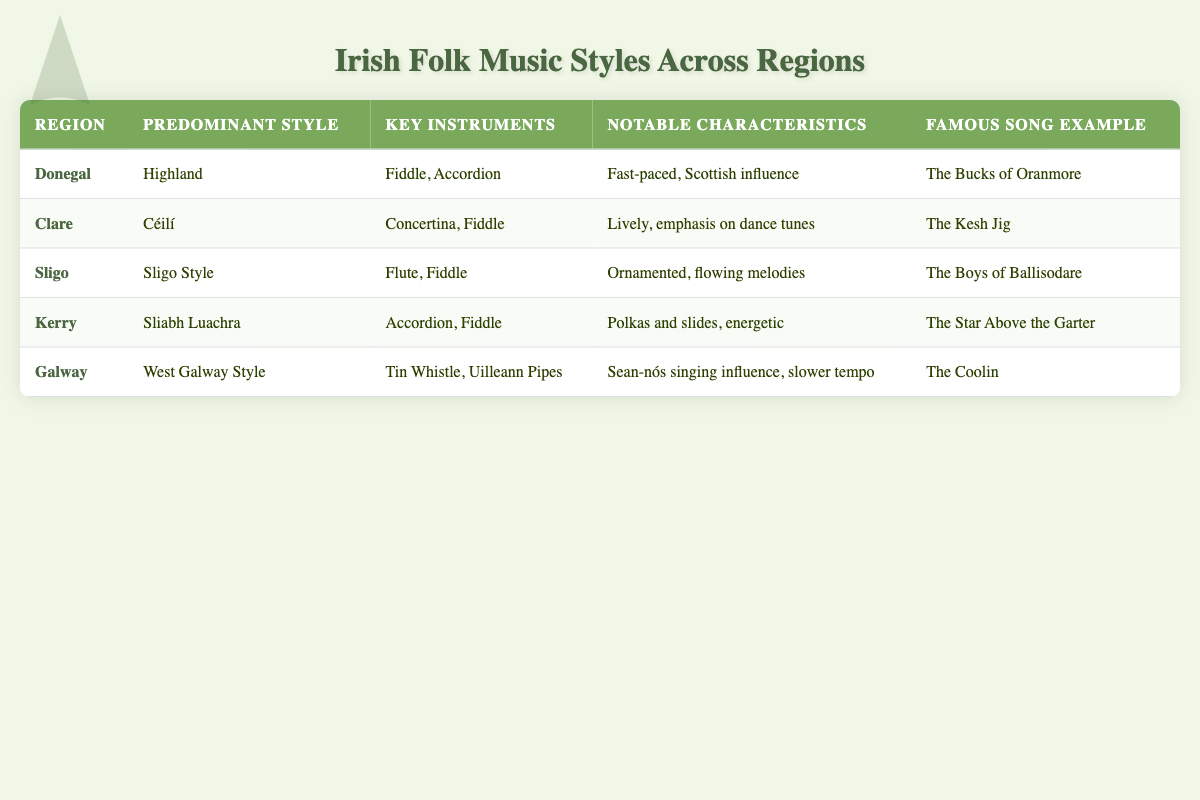What is the predominant style of music in Clare? The table lists Clare under the "Region" column and indicates that the "Predominant Style" is "Céilí."
Answer: Céilí Which region's music style is characterized by fast-paced rhythms and Scottish influence? Referring to the "Notable Characteristics" of Donegal in the table, it states the style is "Fast-paced, Scottish influence."
Answer: Donegal How many different key instruments are listed for the Sliabh Luachra style? Looking at the "Key Instruments" for Kerry, which is associated with the Sliabh Luachra style, it lists "Accordion, Fiddle." Therefore, there are two instruments.
Answer: 2 Is the famous song example for the Galway region "The Boys of Ballisodare"? Checking the "Famous Song Example" column for the Galway region shows it is "The Coolin," not "The Boys of Ballisodare," which belongs to the Sligo region.
Answer: No Which style has an influence from Sean-nós singing and typically features a slower tempo? The table states that the "West Galway Style" is influenced by "Sean-nós singing" with a "slower tempo."
Answer: West Galway Style What are the notable characteristics of the Highland style? The table indicates that the "Notable Characteristics" of the Highland style is "Fast-paced, Scottish influence," which describes how this music style is generally perceived.
Answer: Fast-paced, Scottish influence Which region features polkas and slides, and what is its famous song example? The Sliabh Luachra style from Kerry is noted for "Polkas and slides," and its famous song example is "The Star Above the Garter."
Answer: Kerry; The Star Above the Garter In how many regions is the fiddle a key instrument? By reviewing the "Key Instruments" for each region, the fiddle appears in Donegal, Clare, Sligo, and Kerry, amounting to four regions total.
Answer: 4 What is the difference in notable characteristics between the Sligo Style and the Celtic style? The Sligo Style is characterized as "Ornamented, flowing melodies," whereas the table does not provide any data for a style called Celtic, making this comparison not applicable.
Answer: Not applicable 